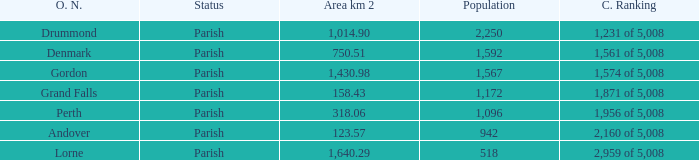What is the area of the parish with a population larger than 1,172 and a census ranking of 1,871 of 5,008? 0.0. 